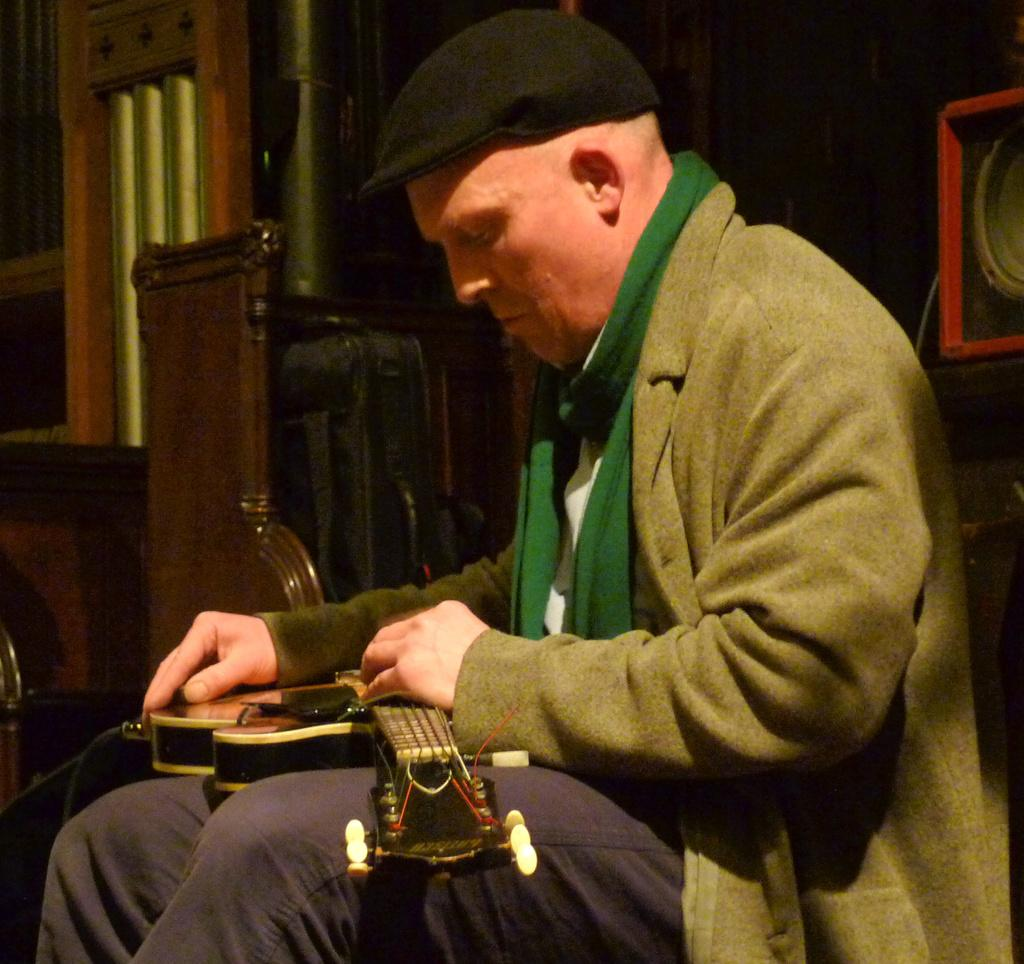What is the person in the image doing? The person is sitting in the image. What is the person holding? The person is holding a musical instrument. Can you describe the background of the image? There is a red color object, a stand, a window, and a few other objects in the background. Are there any mice visible in the image? There are no mice present in the image. What type of umbrella is being used by the person in the image? There is no umbrella present in the image. 